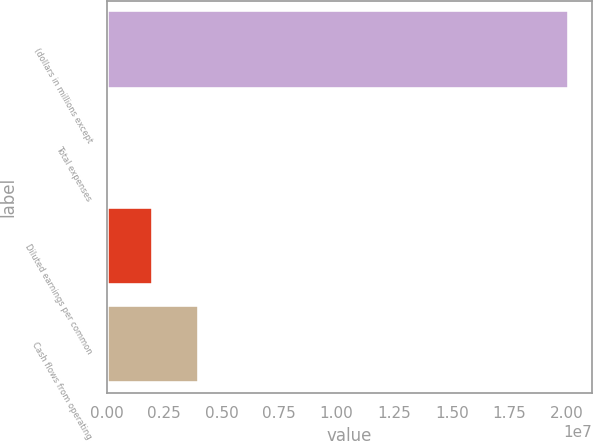<chart> <loc_0><loc_0><loc_500><loc_500><bar_chart><fcel>(dollars in millions except<fcel>Total expenses<fcel>Diluted earnings per common<fcel>Cash flows from operating<nl><fcel>2.0102e+07<fcel>15<fcel>2.01021e+06<fcel>4.02041e+06<nl></chart> 